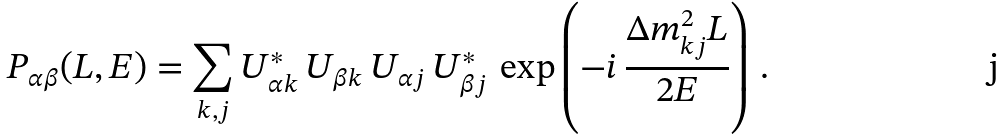<formula> <loc_0><loc_0><loc_500><loc_500>P _ { \alpha \beta } ( L , E ) = \sum _ { k , j } U _ { { \alpha } k } ^ { * } \, U _ { { \beta } k } \, U _ { { \alpha } j } \, U _ { { \beta } j } ^ { * } \, \exp \left ( - i \, \frac { \Delta { m } ^ { 2 } _ { k j } L } { 2 E } \right ) \, .</formula> 